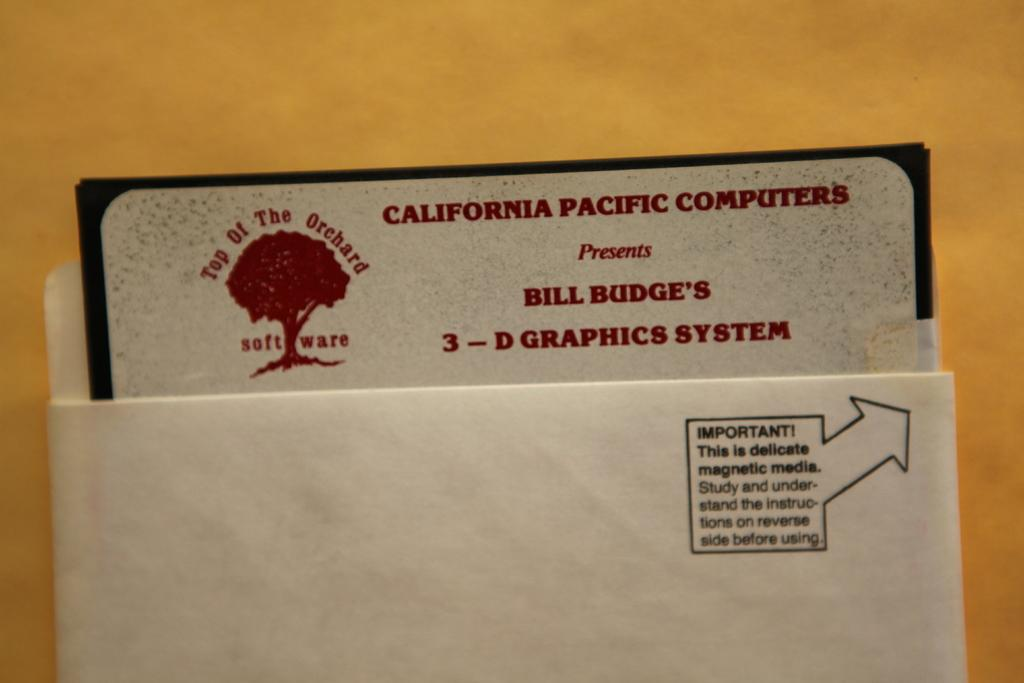<image>
Render a clear and concise summary of the photo. An envelope with a business card for 3 d graphics inside. 